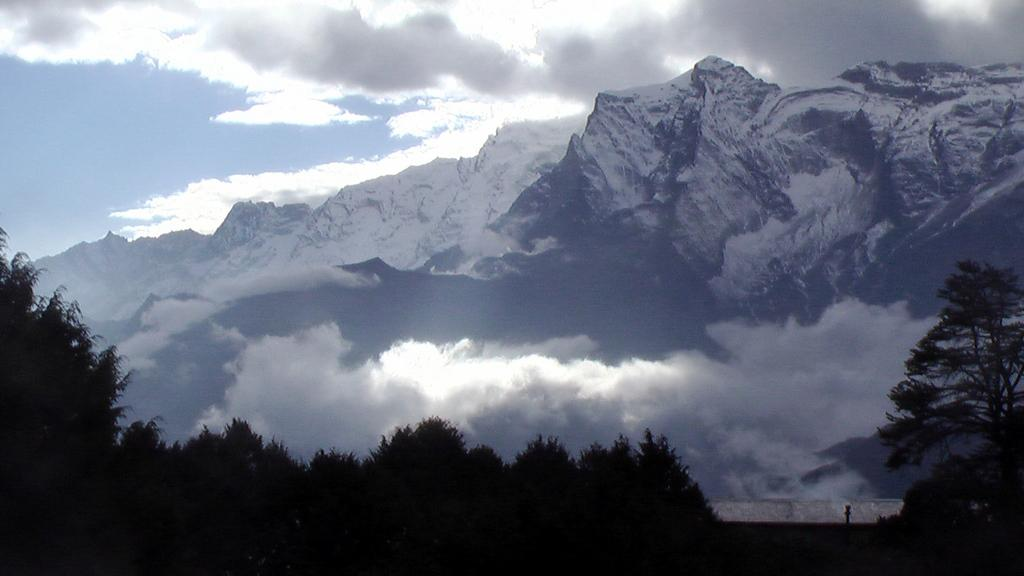What type of natural features can be seen in the image? There are trees and mountains in the image. What is the condition of the mountains in the image? The mountains are covered with snow. What is visible in the sky in the image? Clouds are present in the sky. What type of lace can be seen on the trees in the image? There is no lace present on the trees in the image; they are natural trees with leaves or branches. 